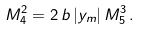Convert formula to latex. <formula><loc_0><loc_0><loc_500><loc_500>M _ { 4 } ^ { 2 } = 2 \, b \, | y _ { m } | \, M _ { 5 } ^ { 3 } \, .</formula> 